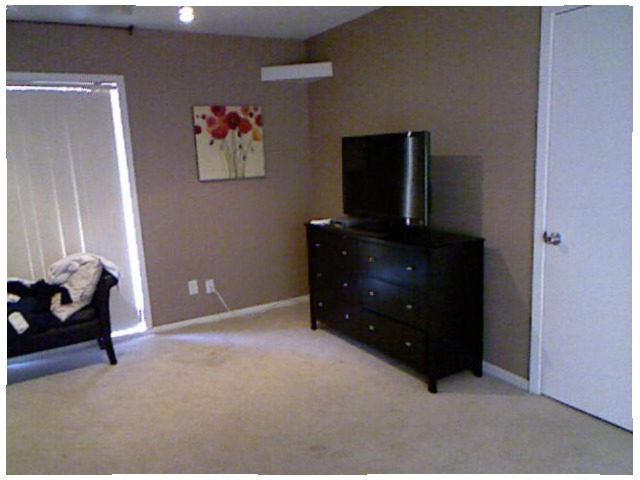<image>
Is the picture on the floor? No. The picture is not positioned on the floor. They may be near each other, but the picture is not supported by or resting on top of the floor. Is there a painting behind the television? No. The painting is not behind the television. From this viewpoint, the painting appears to be positioned elsewhere in the scene. Is the television above the dresser? No. The television is not positioned above the dresser. The vertical arrangement shows a different relationship. Where is the picture in relation to the television? Is it to the left of the television? Yes. From this viewpoint, the picture is positioned to the left side relative to the television. Is there a dresser next to the floor? No. The dresser is not positioned next to the floor. They are located in different areas of the scene. 